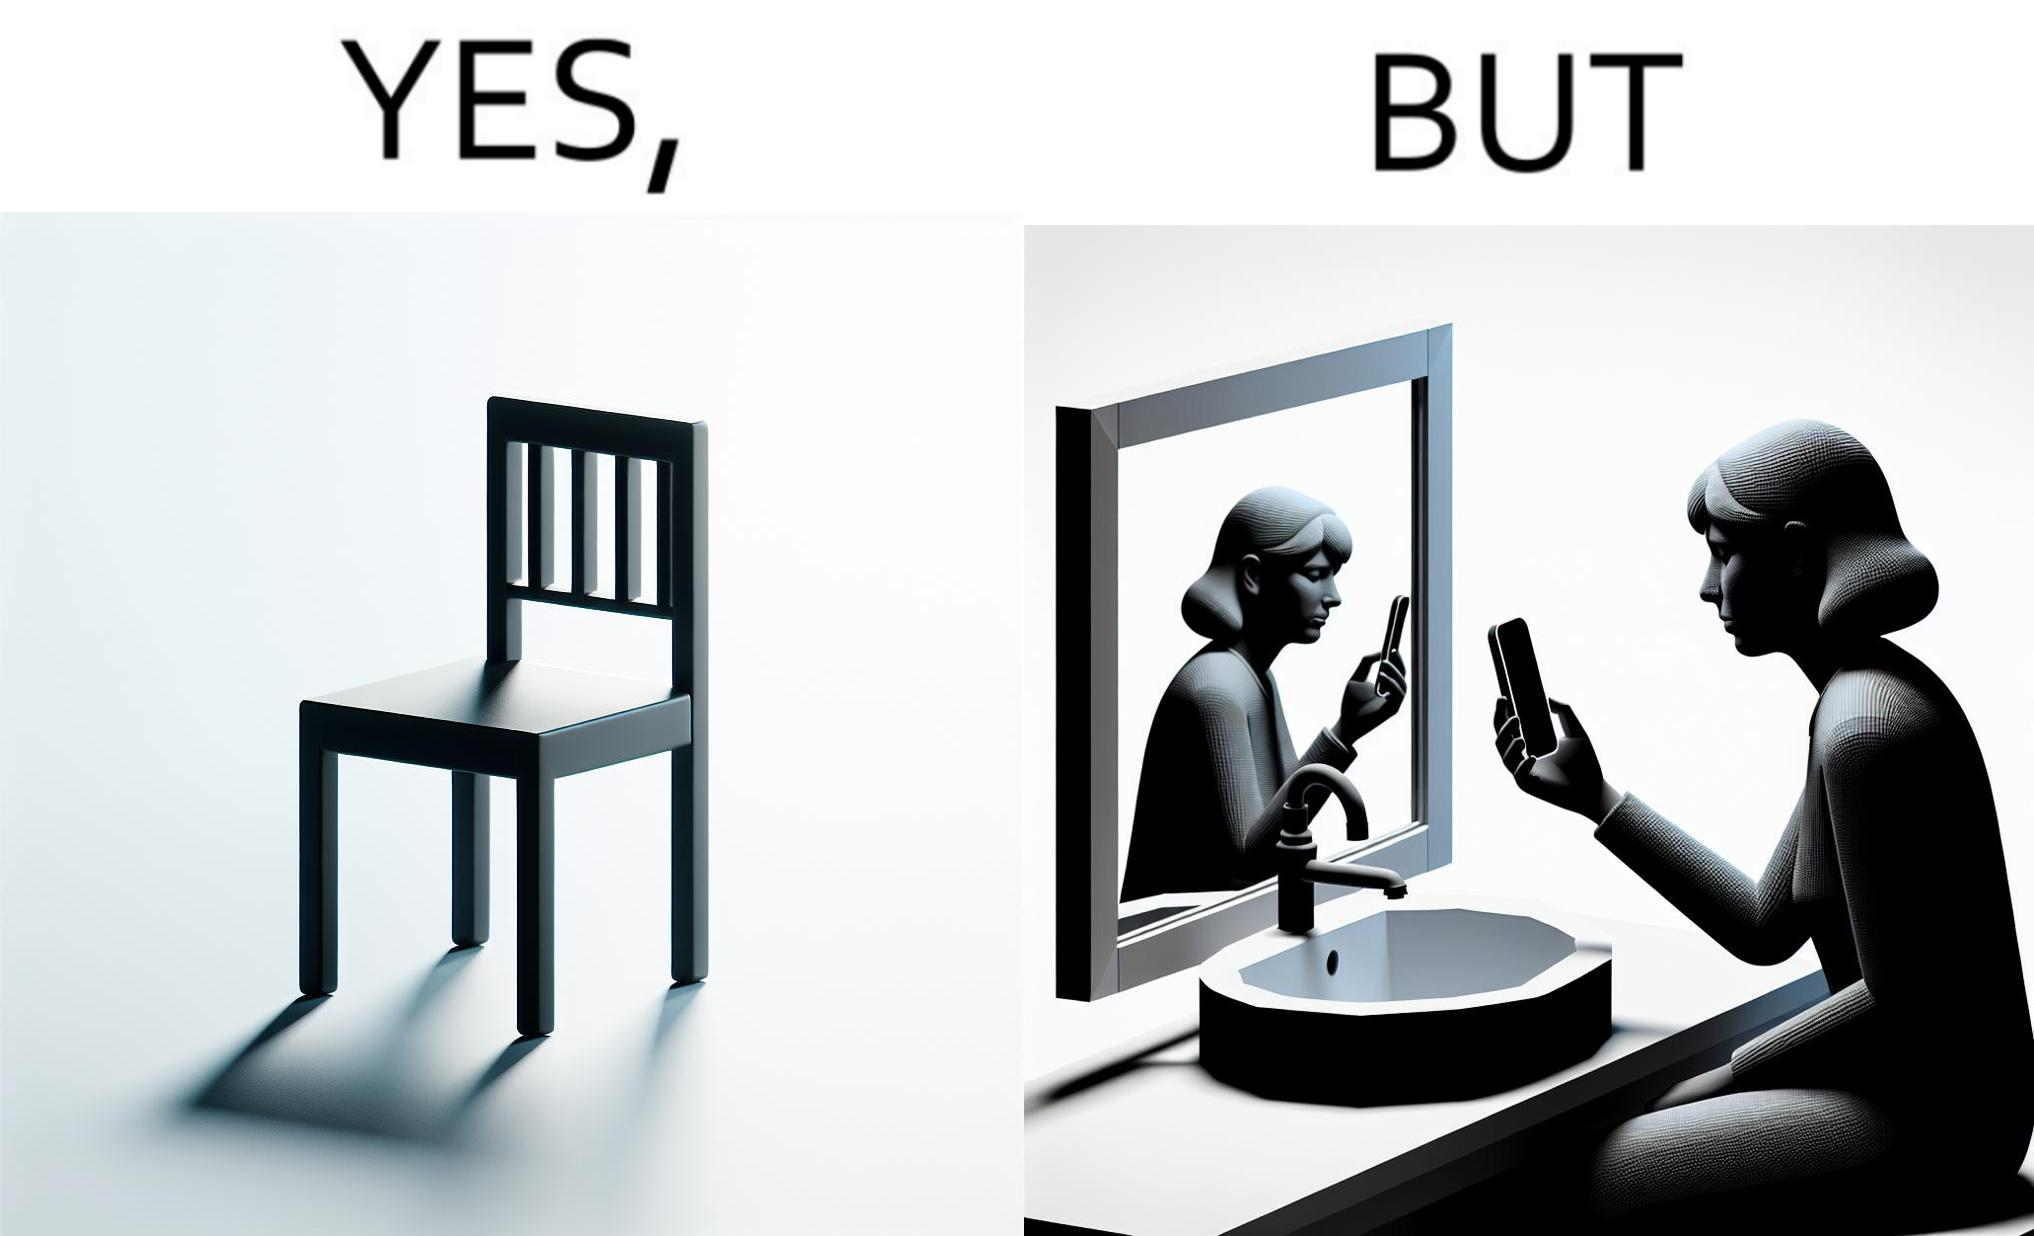Describe what you see in this image. The image is ironical, as a woman is sitting by the sink taking a selfie using a mirror, while not using a chair that is actually meant for sitting. 